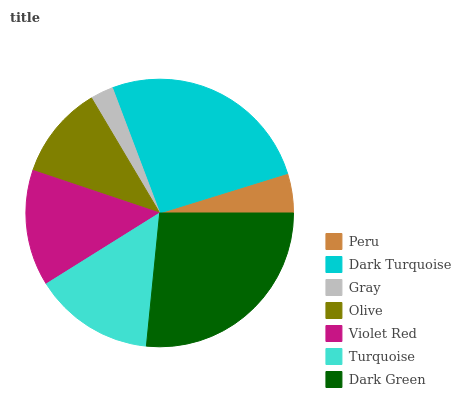Is Gray the minimum?
Answer yes or no. Yes. Is Dark Green the maximum?
Answer yes or no. Yes. Is Dark Turquoise the minimum?
Answer yes or no. No. Is Dark Turquoise the maximum?
Answer yes or no. No. Is Dark Turquoise greater than Peru?
Answer yes or no. Yes. Is Peru less than Dark Turquoise?
Answer yes or no. Yes. Is Peru greater than Dark Turquoise?
Answer yes or no. No. Is Dark Turquoise less than Peru?
Answer yes or no. No. Is Violet Red the high median?
Answer yes or no. Yes. Is Violet Red the low median?
Answer yes or no. Yes. Is Turquoise the high median?
Answer yes or no. No. Is Olive the low median?
Answer yes or no. No. 